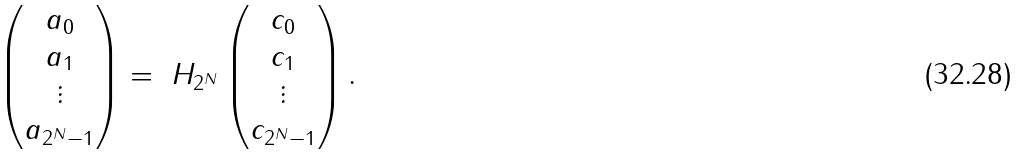<formula> <loc_0><loc_0><loc_500><loc_500>\begin{pmatrix} a _ { 0 } \\ a _ { 1 } \\ \vdots \\ a _ { 2 ^ { N } - 1 } \end{pmatrix} = \ H _ { 2 ^ { N } } \begin{pmatrix} c _ { 0 } \\ c _ { 1 } \\ \vdots \\ c _ { 2 ^ { N } - 1 } \end{pmatrix} . \\</formula> 